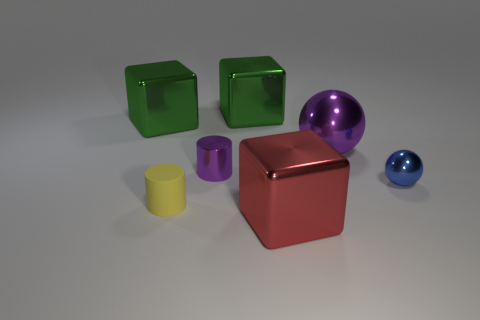The purple ball that is made of the same material as the small purple thing is what size? The size of the purple ball, which appears to be made of the same glossy material as the small purple cylinder, can be described as medium-sized in comparison to other objects in the image, such as the smaller blue ball and the larger green cubes. 